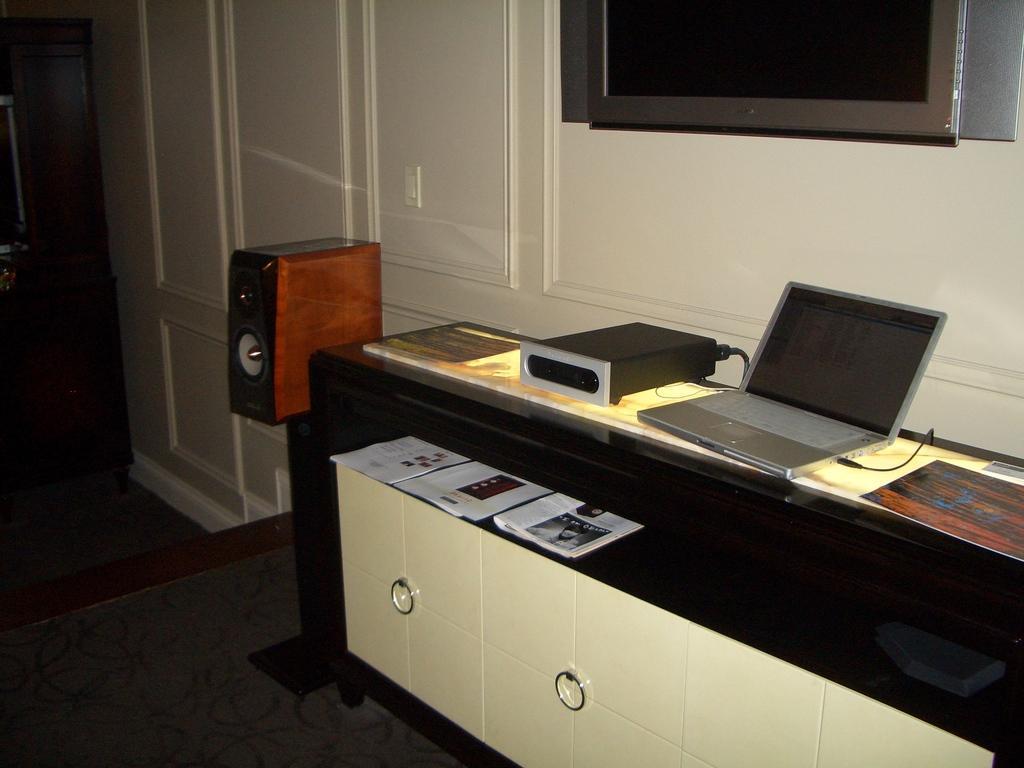Could you give a brief overview of what you see in this image? In this image we can see a table, papers, cupboards, laptop, cable, and devices. Here we can see the floor. In the background we can see wall and a television. 